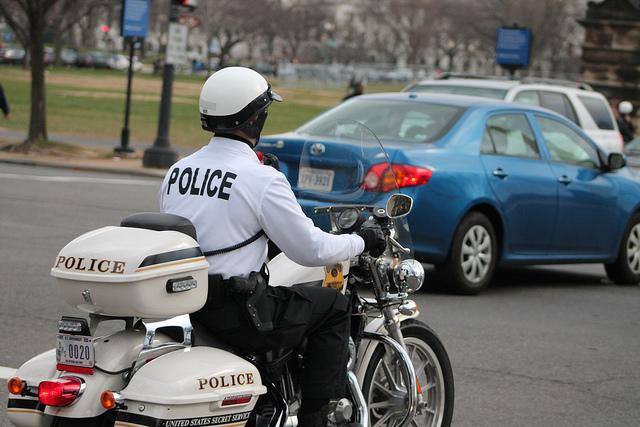What company produced the blue car?
Short answer required. Toyota. What is the color of the police bike?
Concise answer only. White. What profession is the man?
Give a very brief answer. Police officer. 